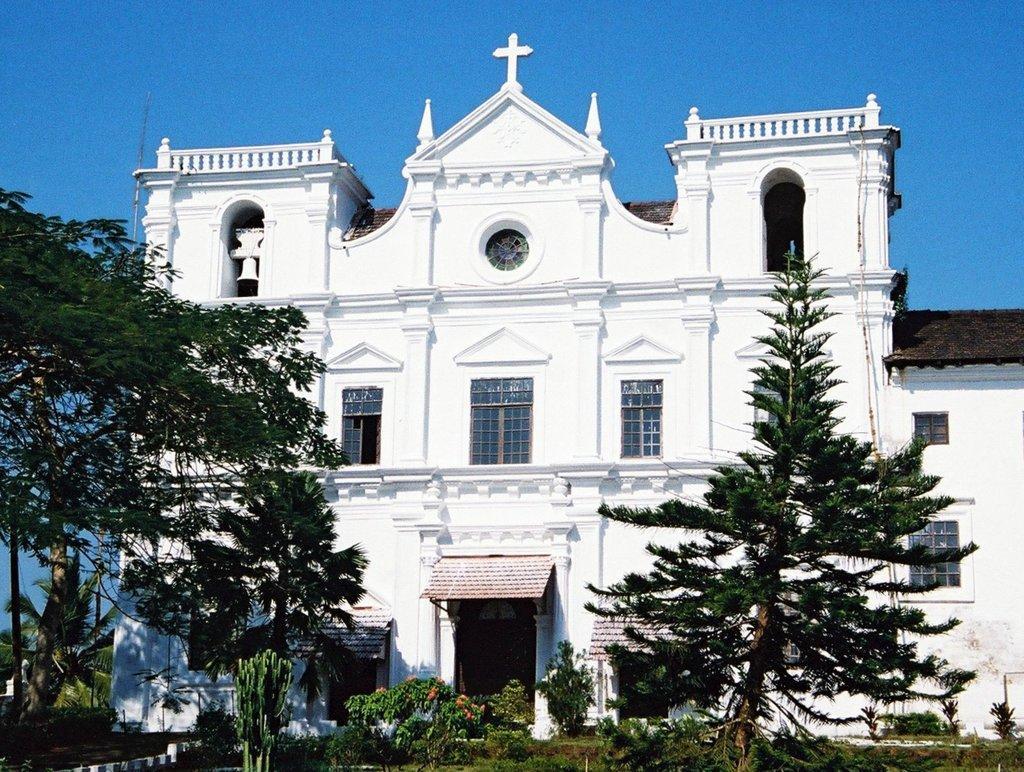Can you describe this image briefly? In this image we can see the church in the middle of the image and there are some plants, trees and flowers. At the top we can see the sky. 